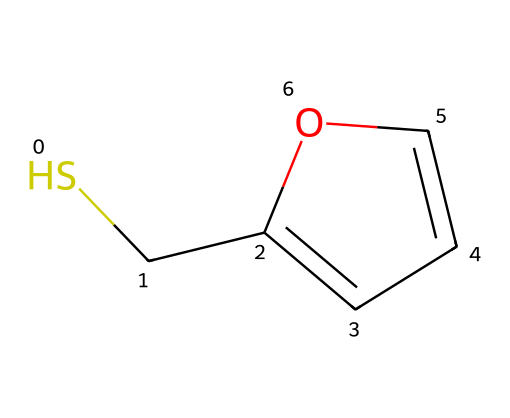what is the molecular formula of furfuryl mercaptan? To find the molecular formula, count the number of each type of atom in the SMILES representation. The "S" indicates one sulfur atom, "C" indicates five carbon atoms, and "H" atoms are implicit based on tetravalency of carbon and valency of sulfur. The total counts yield C5H6S.
Answer: C5H6S how many rings are present in the structure of furfuryl mercaptan? The SMILES notation shows a "C1" and a corresponding "C" indicating a closure point of a ring. This signifies that there is one cyclic structure in the compound.
Answer: one which part of the chemical structure is responsible for its aroma? The presence of the sulfur atom in this compound is essential as sulfur-containing compounds like thiols are known to contribute to strong aromas. This specific compound's sulfur functionality is tied to the distinctive coffee aroma.
Answer: sulfur how many double bonds does furfuryl mercaptan have? The structure indicates a double bond in the ring (C=C) as per the "CC=CO" notation in the SMILES. Thus, there is one double bond present in the molecule.
Answer: one is furfuryl mercaptan a polar or nonpolar molecule? The presence of the polar sulfur-hydrogen bond suggests that the molecule has polar characteristics despite the presence of a carbon ring which could lend some nonpolar properties. Upon analysis, furfuryl mercaptan functions more towards the polar side.
Answer: polar what functional group is present in furfuryl mercaptan? Analyzing the molecular structure, the presence of the -SH (thiol) group indicates that the compound contains a mercaptan functional group, which is characteristic of sulfur-containing compounds.
Answer: mercaptan 